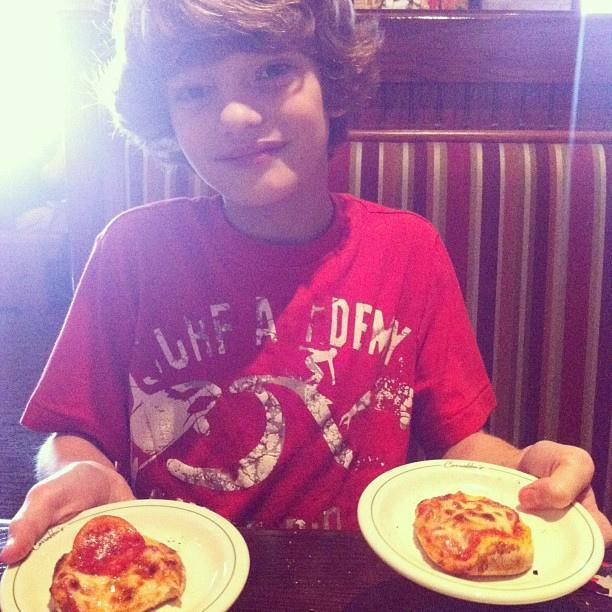How many pizzas can be seen?
Give a very brief answer. 2. How many dining tables are visible?
Give a very brief answer. 1. How many chairs are in the picture?
Give a very brief answer. 2. 